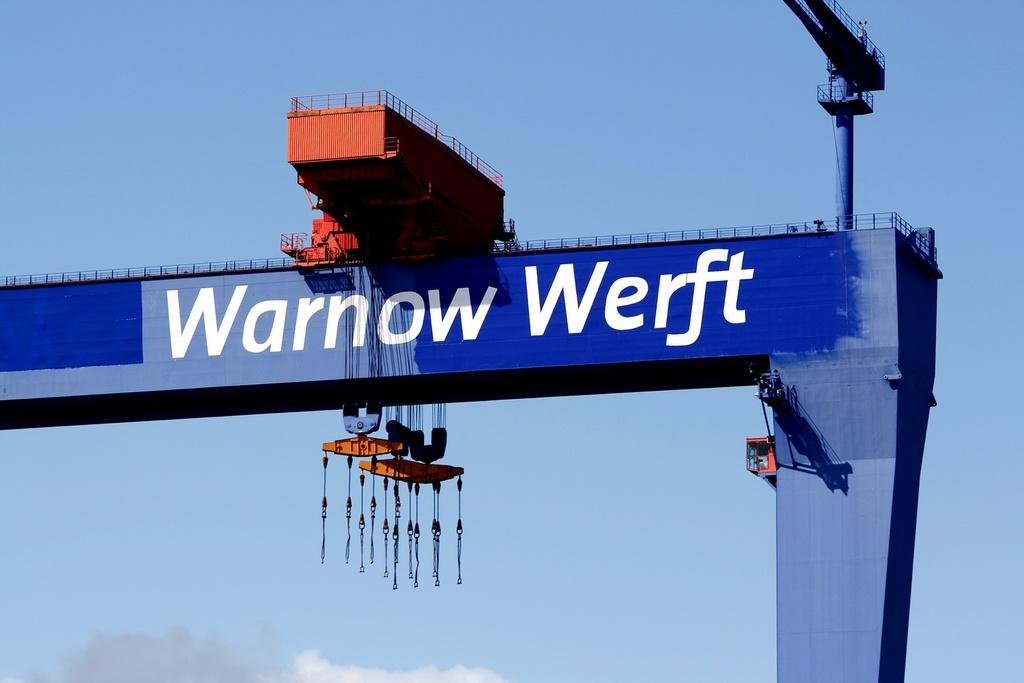<image>
Present a compact description of the photo's key features. a crane with the words Warnow Werft written on it 